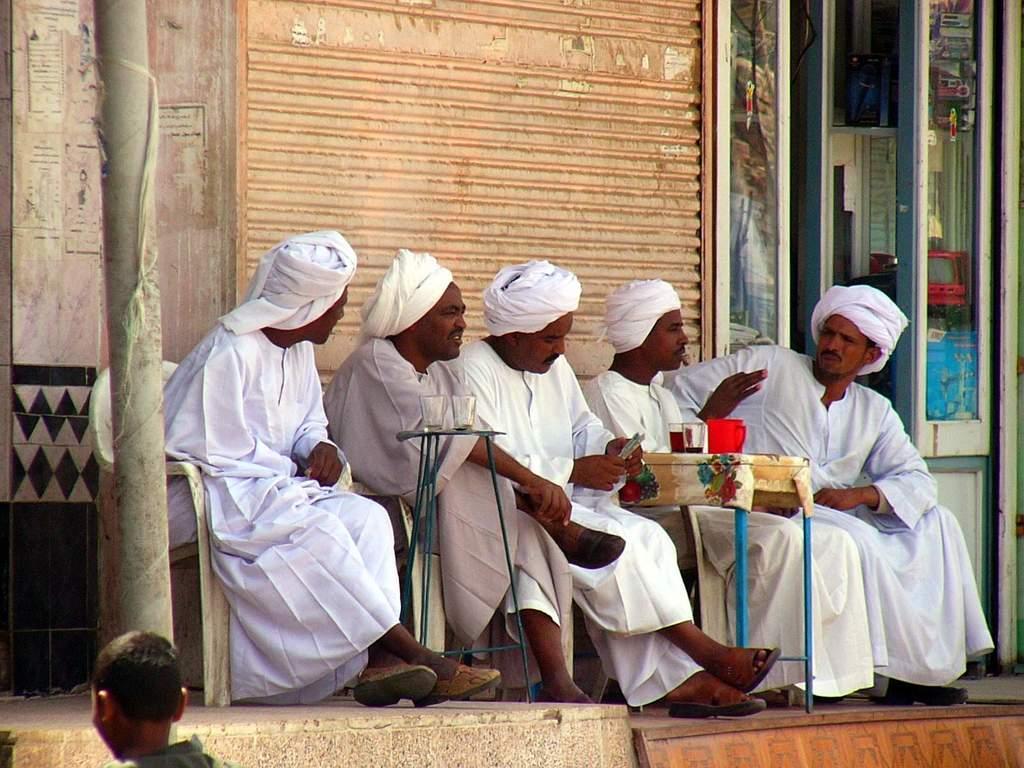How would you summarize this image in a sentence or two? In the image we can see five men sitting on the chair, they are wearing clothes and cloth hat. There is a table, on the table, we can see glass and water jug. Here we can see shutter, pole and glass door. 